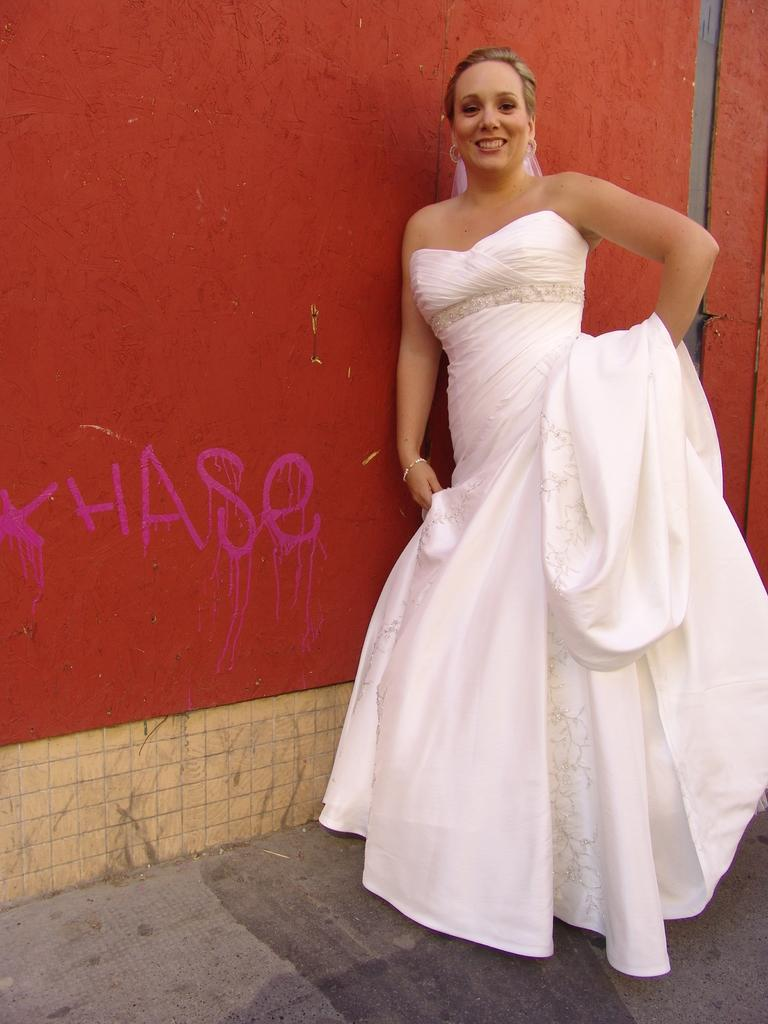Who is present in the image? There is a woman in the image. What is the woman wearing? The woman is wearing a white dress. Where is the woman located in the image? The woman is standing near a wall. What type of cap is the woman wearing in the image? There is no cap visible in the image; the woman is wearing a white dress. 